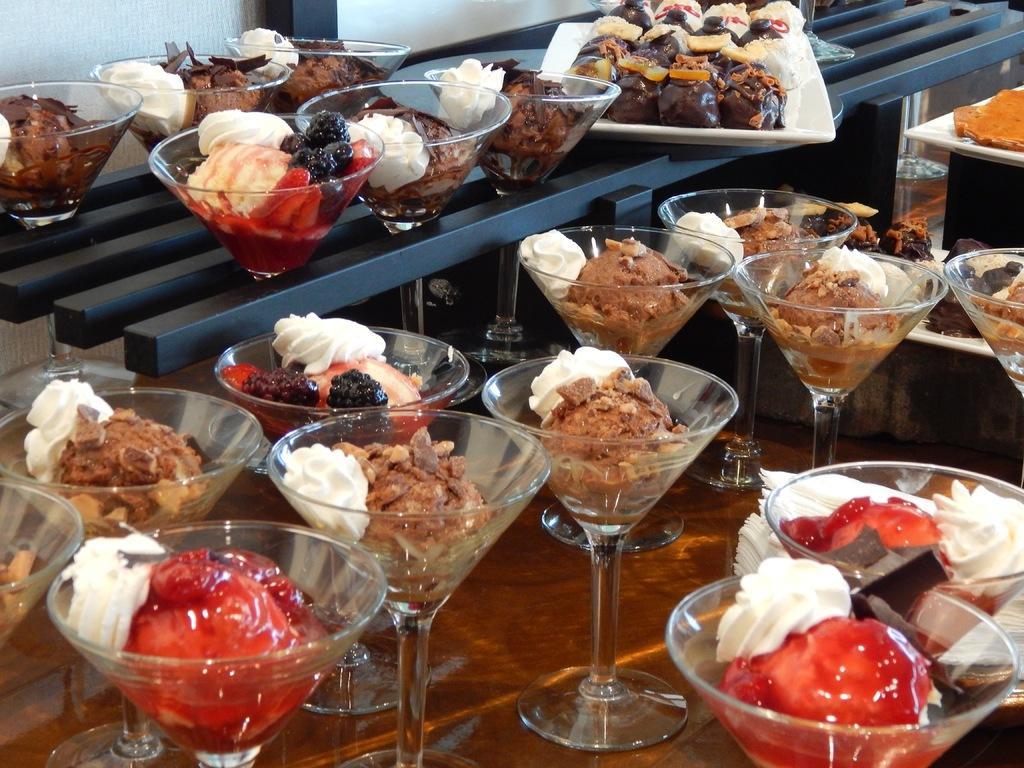How would you summarize this image in a sentence or two? In this image we can see the ice cream and cakes in the glasses which is on the wooden table. In the background we can see the food items in a white plate. 